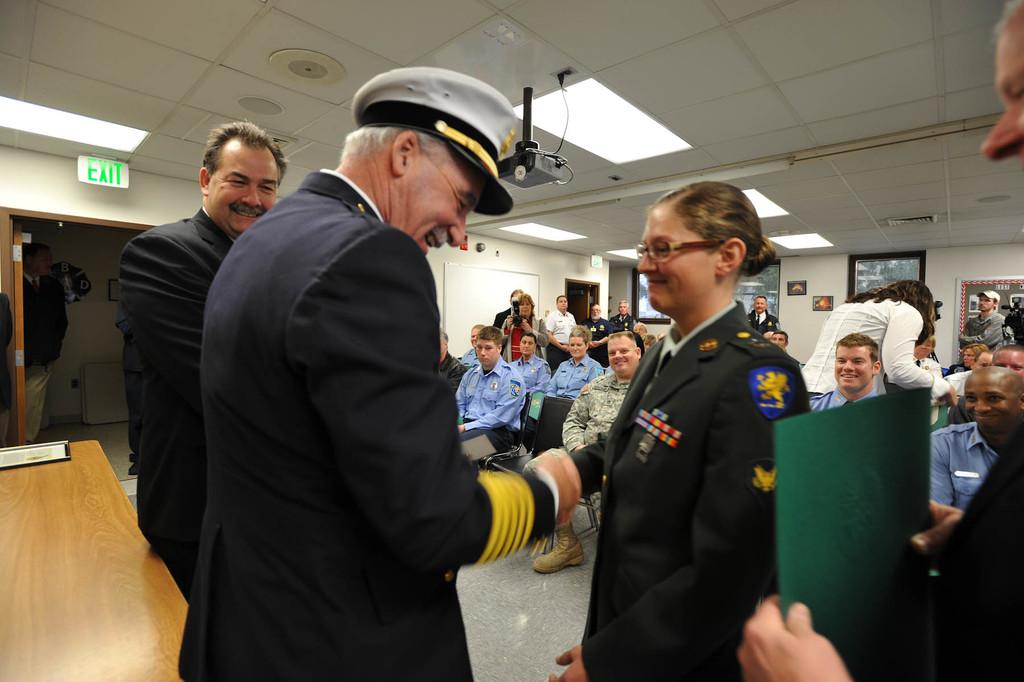How many people are in the image? There is a group of people in the image. What is the man holding in the image? The man is holding a file. What device is used for displaying images in the image? There is a projector in the image. What is used to indicate the exit location in the image? There is an exit board in the image. What can be seen on the wall in the image? Pictures are present on the wall. What type of book is being read by the dolls in the image? There are no dolls or books present in the image. 